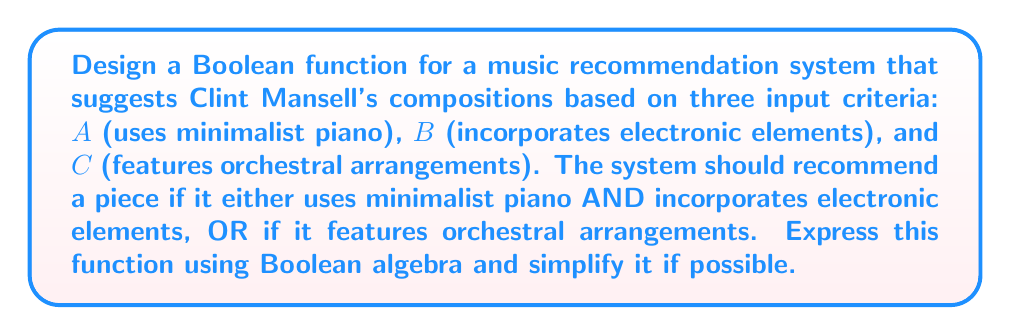Teach me how to tackle this problem. Let's approach this step-by-step:

1) First, we need to translate the given conditions into a Boolean expression:
   - Condition 1: Uses minimalist piano AND incorporates electronic elements
   - Condition 2: Features orchestral arrangements
   
   The piece should be recommended if either of these conditions is true.

2) We can express this as:
   $$ F = (A \cdot B) + C $$

   Where $\cdot$ represents AND, and $+$ represents OR.

3) This expression is already in its simplest form, known as the sum-of-products (SOP) form. It cannot be simplified further using Boolean algebra laws.

4) To verify, we can create a truth table:

   | A | B | C | F |
   |---|---|---|---|
   | 0 | 0 | 0 | 0 |
   | 0 | 0 | 1 | 1 |
   | 0 | 1 | 0 | 0 |
   | 0 | 1 | 1 | 1 |
   | 1 | 0 | 0 | 0 |
   | 1 | 0 | 1 | 1 |
   | 1 | 1 | 0 | 1 |
   | 1 | 1 | 1 | 1 |

5) The truth table confirms that the function recommends a piece when either $(A \cdot B)$ is true or when $C$ is true, which matches our original requirements.

Therefore, the Boolean function $F = (A \cdot B) + C$ accurately represents the desired music recommendation system for Clint Mansell's compositions.
Answer: $F = (A \cdot B) + C$ 